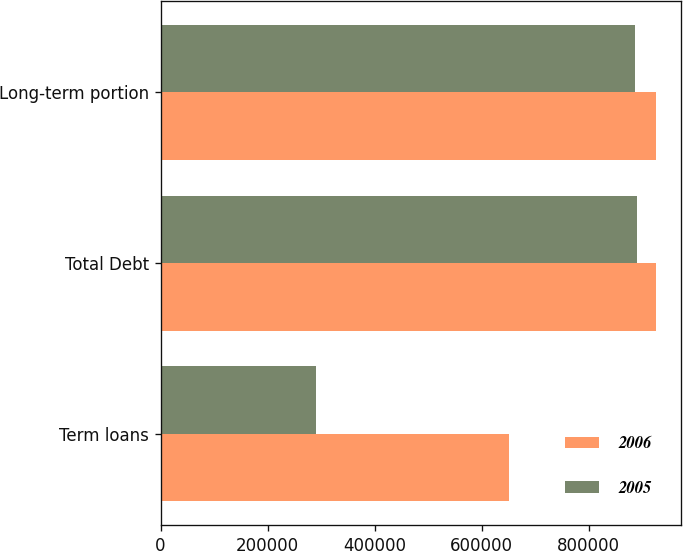Convert chart to OTSL. <chart><loc_0><loc_0><loc_500><loc_500><stacked_bar_chart><ecel><fcel>Term loans<fcel>Total Debt<fcel>Long-term portion<nl><fcel>2006<fcel>650000<fcel>925000<fcel>925000<nl><fcel>2005<fcel>289849<fcel>889846<fcel>886903<nl></chart> 